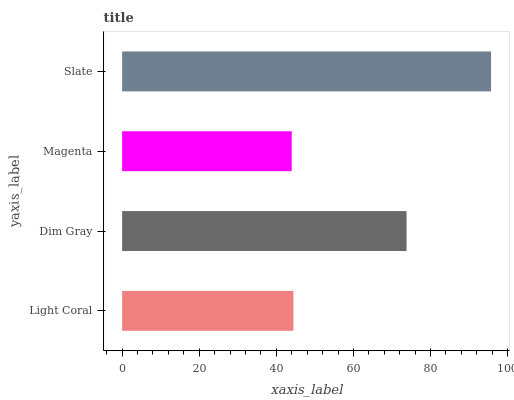Is Magenta the minimum?
Answer yes or no. Yes. Is Slate the maximum?
Answer yes or no. Yes. Is Dim Gray the minimum?
Answer yes or no. No. Is Dim Gray the maximum?
Answer yes or no. No. Is Dim Gray greater than Light Coral?
Answer yes or no. Yes. Is Light Coral less than Dim Gray?
Answer yes or no. Yes. Is Light Coral greater than Dim Gray?
Answer yes or no. No. Is Dim Gray less than Light Coral?
Answer yes or no. No. Is Dim Gray the high median?
Answer yes or no. Yes. Is Light Coral the low median?
Answer yes or no. Yes. Is Slate the high median?
Answer yes or no. No. Is Magenta the low median?
Answer yes or no. No. 